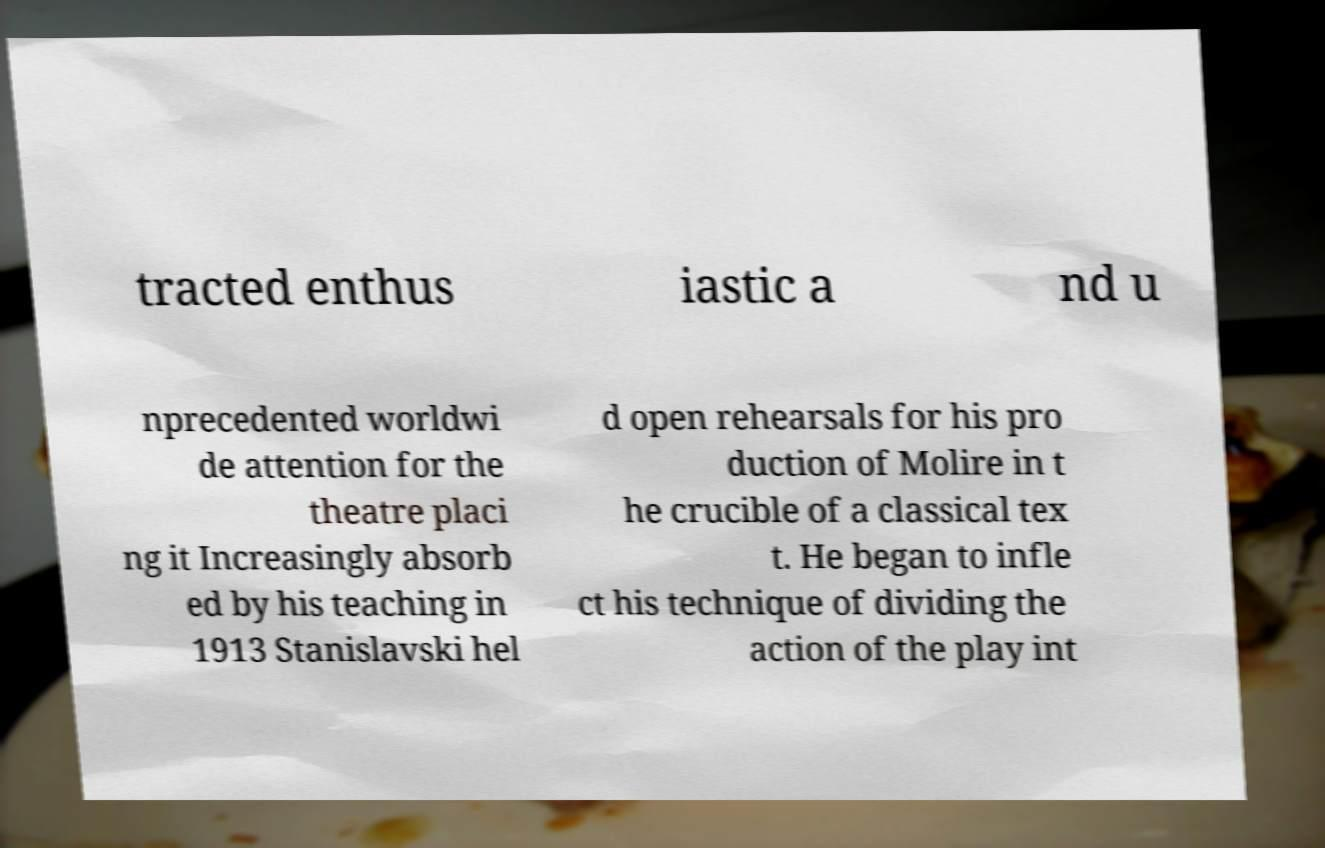For documentation purposes, I need the text within this image transcribed. Could you provide that? tracted enthus iastic a nd u nprecedented worldwi de attention for the theatre placi ng it Increasingly absorb ed by his teaching in 1913 Stanislavski hel d open rehearsals for his pro duction of Molire in t he crucible of a classical tex t. He began to infle ct his technique of dividing the action of the play int 